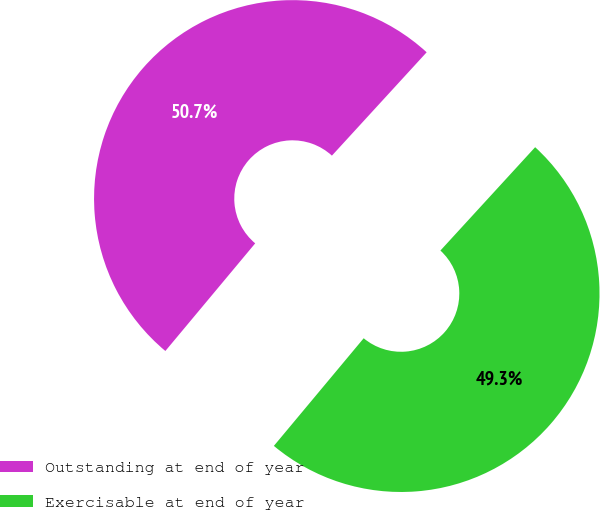Convert chart to OTSL. <chart><loc_0><loc_0><loc_500><loc_500><pie_chart><fcel>Outstanding at end of year<fcel>Exercisable at end of year<nl><fcel>50.74%<fcel>49.26%<nl></chart> 